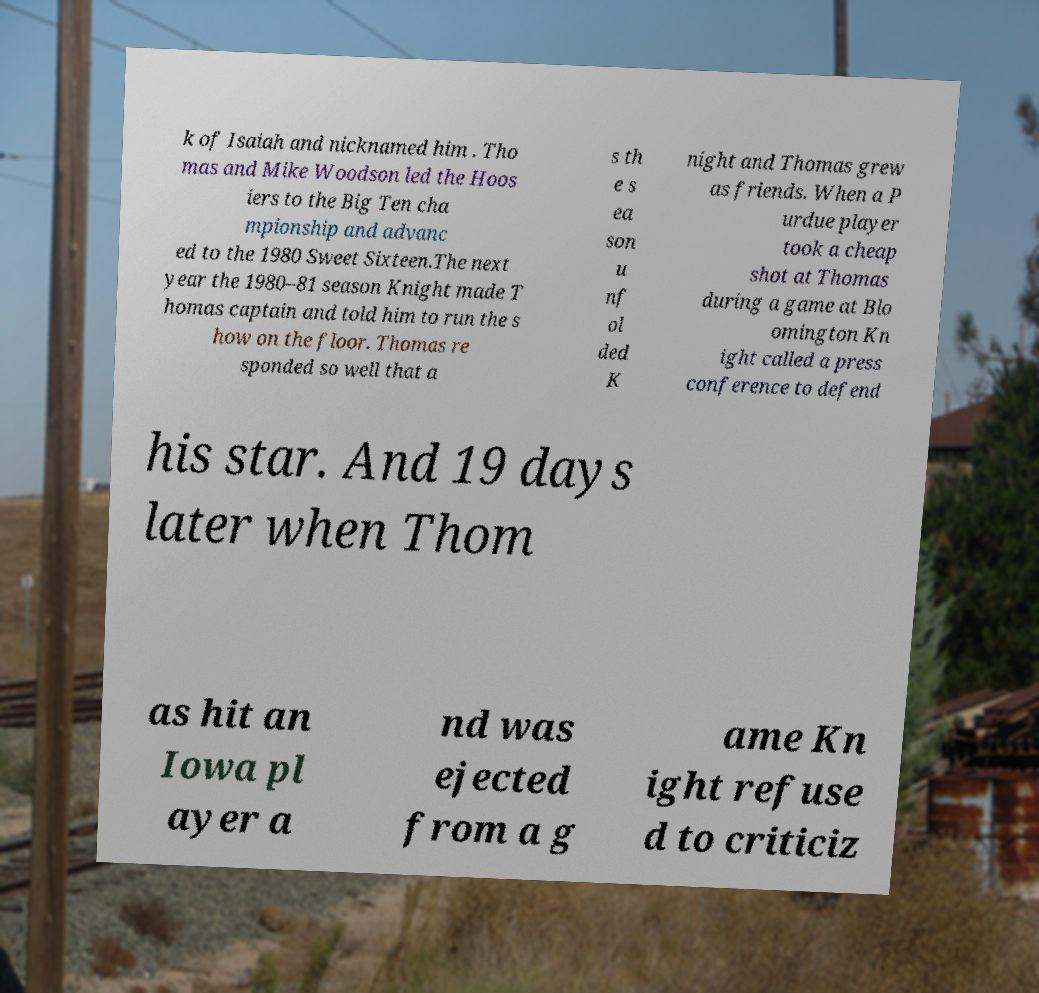For documentation purposes, I need the text within this image transcribed. Could you provide that? k of Isaiah and nicknamed him . Tho mas and Mike Woodson led the Hoos iers to the Big Ten cha mpionship and advanc ed to the 1980 Sweet Sixteen.The next year the 1980–81 season Knight made T homas captain and told him to run the s how on the floor. Thomas re sponded so well that a s th e s ea son u nf ol ded K night and Thomas grew as friends. When a P urdue player took a cheap shot at Thomas during a game at Blo omington Kn ight called a press conference to defend his star. And 19 days later when Thom as hit an Iowa pl ayer a nd was ejected from a g ame Kn ight refuse d to criticiz 